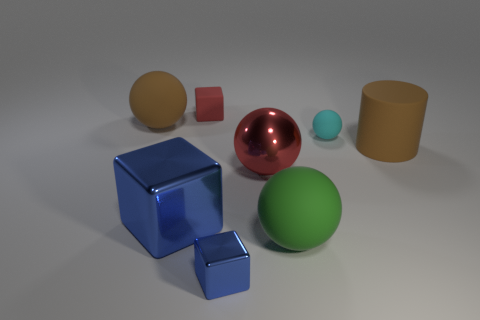Subtract 1 balls. How many balls are left? 3 Add 2 tiny shiny cubes. How many objects exist? 10 Subtract all cubes. How many objects are left? 5 Subtract 1 red cubes. How many objects are left? 7 Subtract all small blue metal things. Subtract all big yellow metal cylinders. How many objects are left? 7 Add 6 small objects. How many small objects are left? 9 Add 2 small things. How many small things exist? 5 